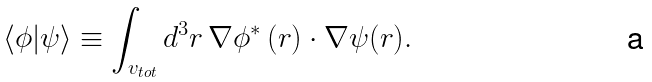Convert formula to latex. <formula><loc_0><loc_0><loc_500><loc_500>\langle \phi | \psi \rangle \equiv \int _ { v _ { t o t } } d ^ { 3 } r \, { \nabla } \phi ^ { * } \, ( { r } ) \cdot { \nabla } \psi ( { r } ) .</formula> 